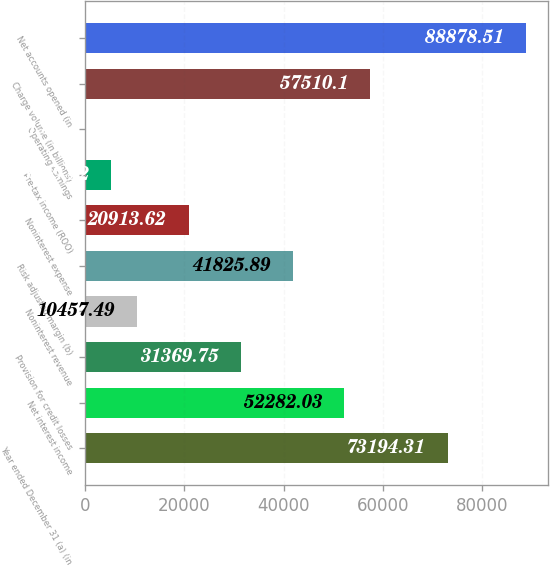Convert chart. <chart><loc_0><loc_0><loc_500><loc_500><bar_chart><fcel>Year ended December 31 (a) (in<fcel>Net interest income<fcel>Provision for credit losses<fcel>Noninterest revenue<fcel>Risk adjusted margin (b)<fcel>Noninterest expense<fcel>Pre-tax income (ROO)<fcel>Operating earnings<fcel>Charge volume (in billions)<fcel>Net accounts opened (in<nl><fcel>73194.3<fcel>52282<fcel>31369.8<fcel>10457.5<fcel>41825.9<fcel>20913.6<fcel>5229.42<fcel>1.35<fcel>57510.1<fcel>88878.5<nl></chart> 